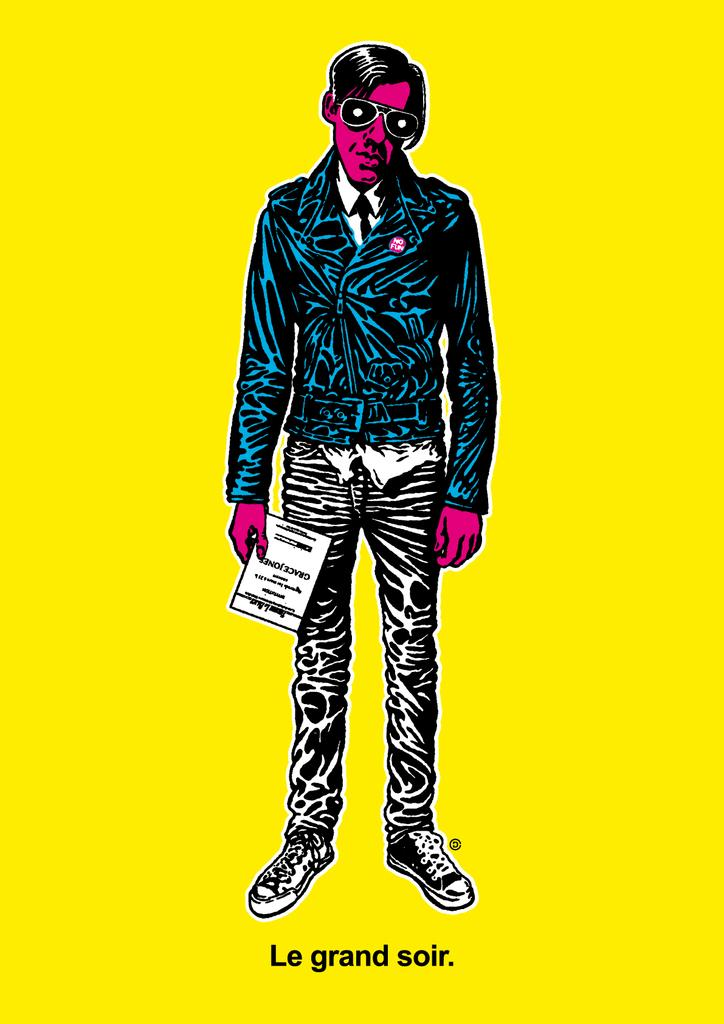What type of image is shown in the animation? The image is animated. What is the main subject of the animation? The animated image depicts a person. What type of wheel is used by the person in the animation? There is no wheel present in the animation; it depicts a person without any visible objects or tools. 